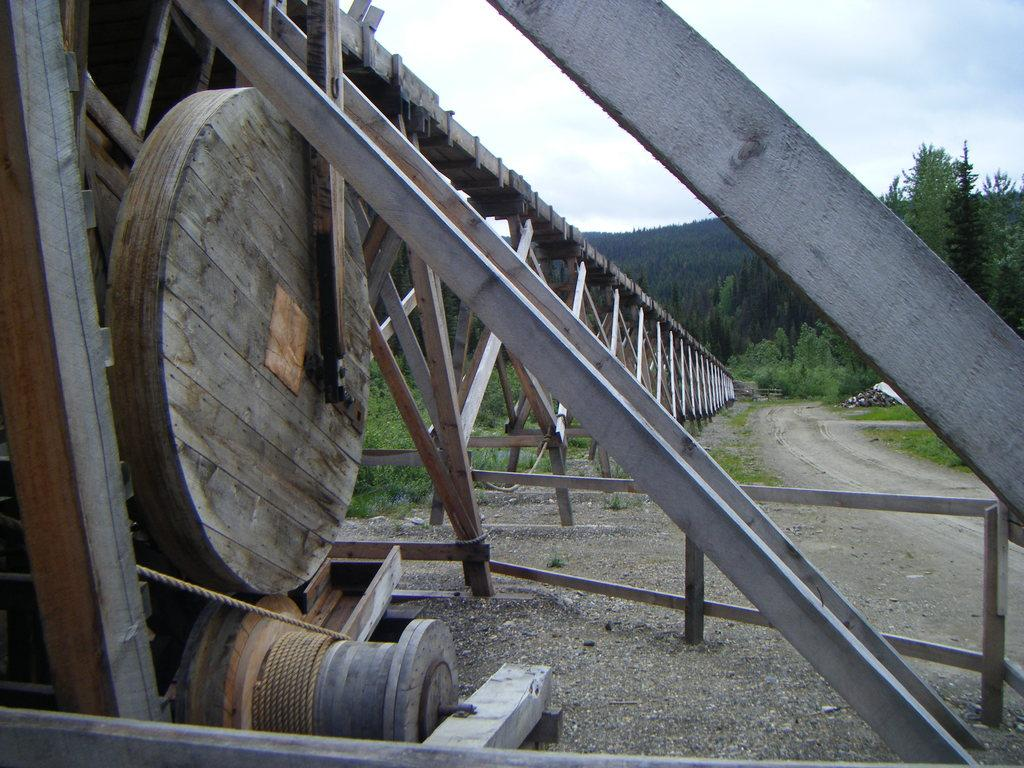What type of pathway can be seen in the image? There is a road in the image. What natural elements are present in the image? There are trees in the image. What type of material is present on the ground in the image? Stones are present in the image. What object can be seen tied or hanging in the image? There is a rope in the image. What type of barrier can be seen in the image? A fence is visible in the image. What is visible in the background of the image? The sky is visible in the background of the image. What can be seen in the sky in the image? Clouds are present in the sky. What type of scent can be detected from the image? There is no information about a scent in the image, as it is a visual representation. What type of badge is visible on the fence in the image? There is no badge present on the fence in the image. 